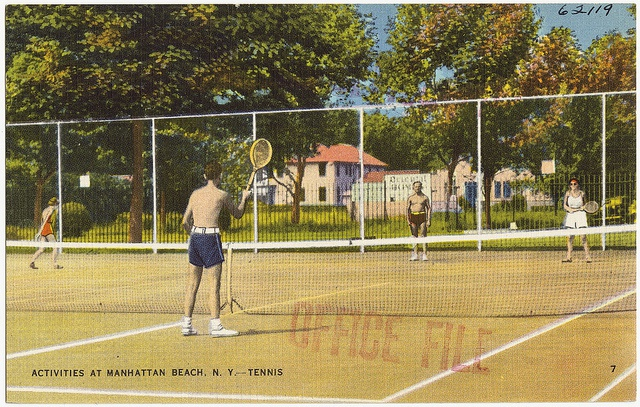Describe the objects in this image and their specific colors. I can see people in white, gray, tan, and olive tones, people in white, beige, tan, and gray tones, people in white, tan, olive, maroon, and gray tones, people in white, tan, and olive tones, and tennis racket in white, tan, khaki, and gray tones in this image. 